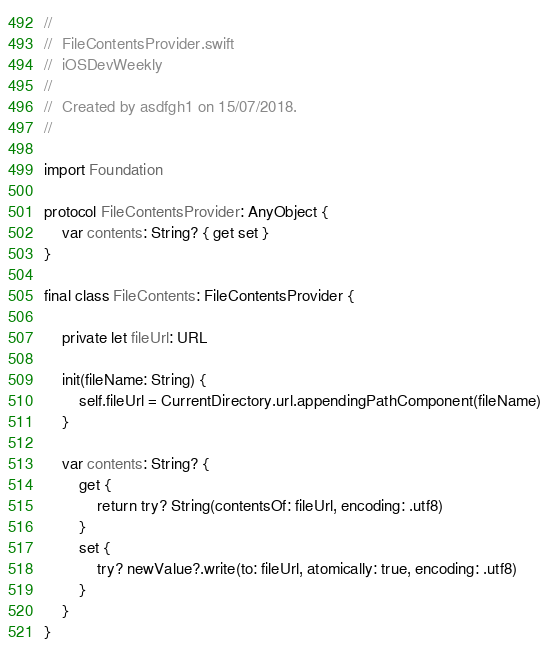Convert code to text. <code><loc_0><loc_0><loc_500><loc_500><_Swift_>//
//  FileContentsProvider.swift
//  iOSDevWeekly
//
//  Created by asdfgh1 on 15/07/2018.
//

import Foundation

protocol FileContentsProvider: AnyObject {
    var contents: String? { get set }
}

final class FileContents: FileContentsProvider {

    private let fileUrl: URL

    init(fileName: String) {
        self.fileUrl = CurrentDirectory.url.appendingPathComponent(fileName)
    }

    var contents: String? {
        get {
            return try? String(contentsOf: fileUrl, encoding: .utf8)
        }
        set {
            try? newValue?.write(to: fileUrl, atomically: true, encoding: .utf8)
        }
    }
}
</code> 